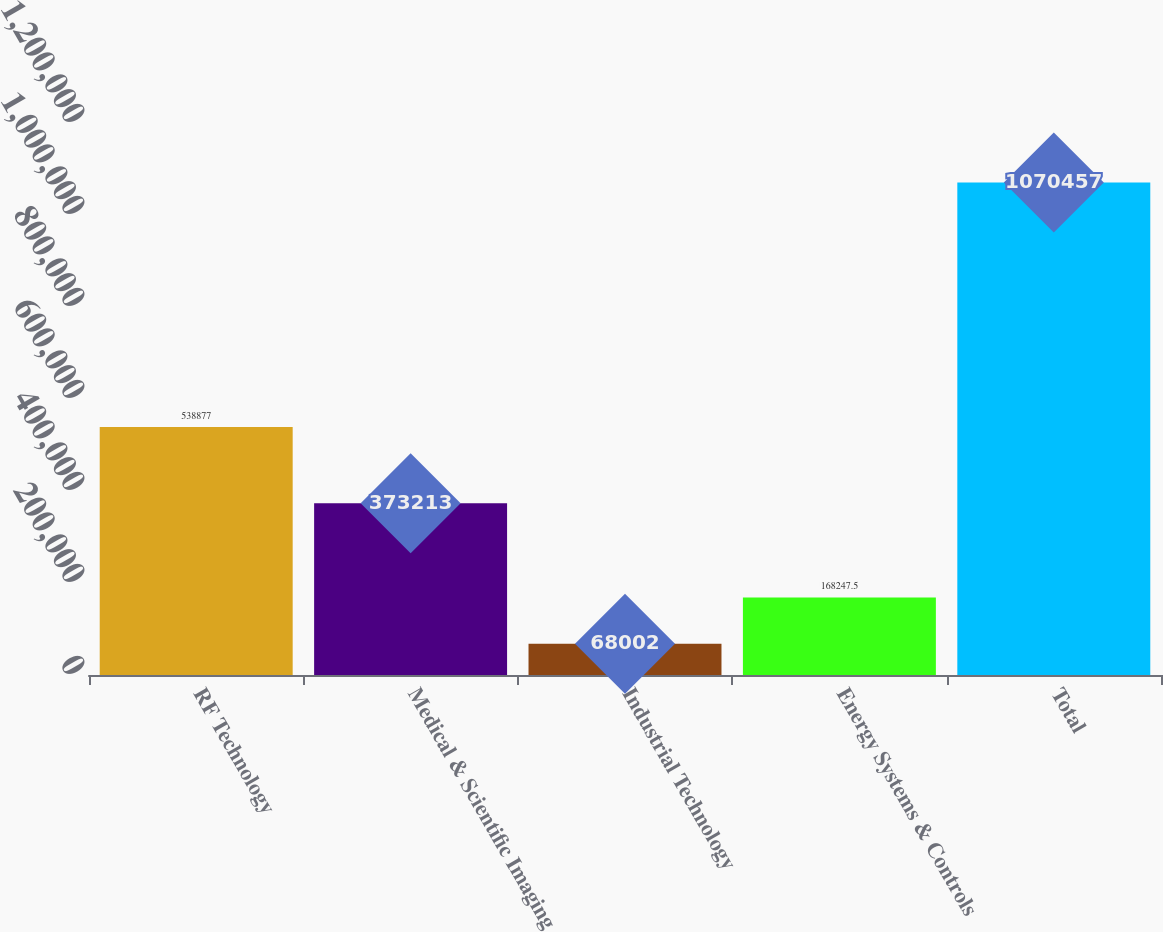Convert chart to OTSL. <chart><loc_0><loc_0><loc_500><loc_500><bar_chart><fcel>RF Technology<fcel>Medical & Scientific Imaging<fcel>Industrial Technology<fcel>Energy Systems & Controls<fcel>Total<nl><fcel>538877<fcel>373213<fcel>68002<fcel>168248<fcel>1.07046e+06<nl></chart> 